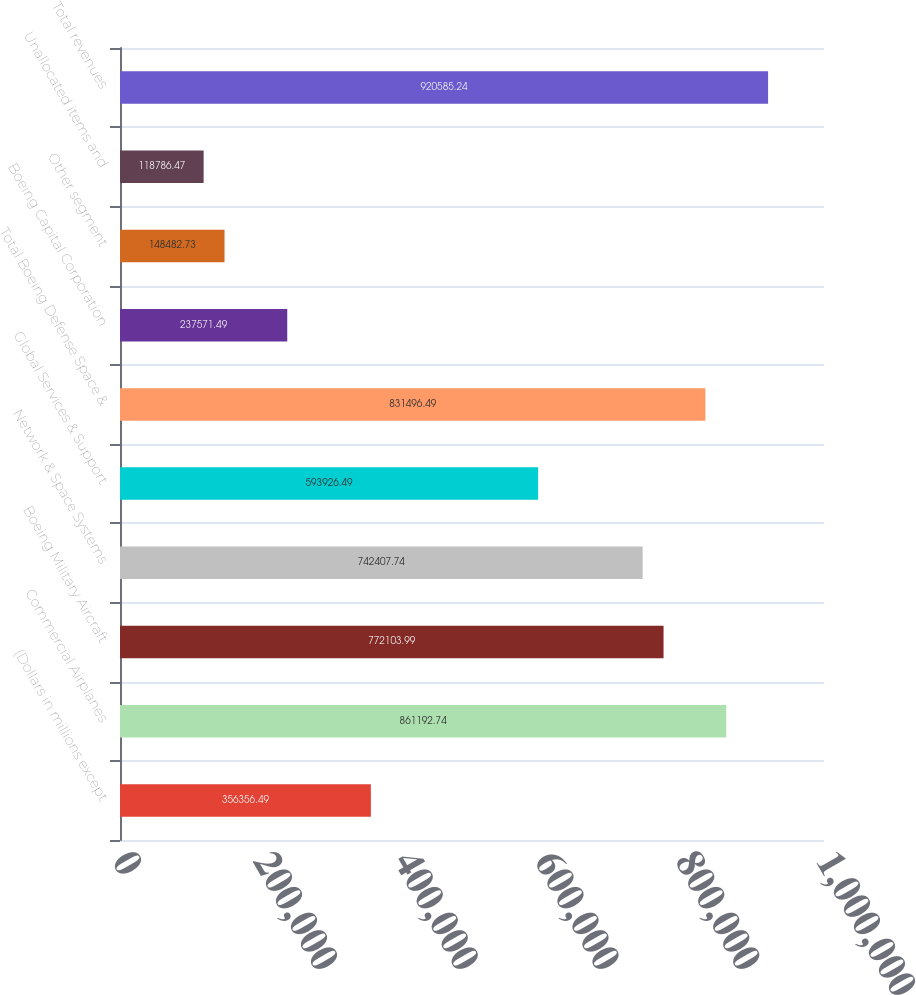Convert chart to OTSL. <chart><loc_0><loc_0><loc_500><loc_500><bar_chart><fcel>(Dollars in millions except<fcel>Commercial Airplanes<fcel>Boeing Military Aircraft<fcel>Network & Space Systems<fcel>Global Services & Support<fcel>Total Boeing Defense Space &<fcel>Boeing Capital Corporation<fcel>Other segment<fcel>Unallocated items and<fcel>Total revenues<nl><fcel>356356<fcel>861193<fcel>772104<fcel>742408<fcel>593926<fcel>831496<fcel>237571<fcel>148483<fcel>118786<fcel>920585<nl></chart> 